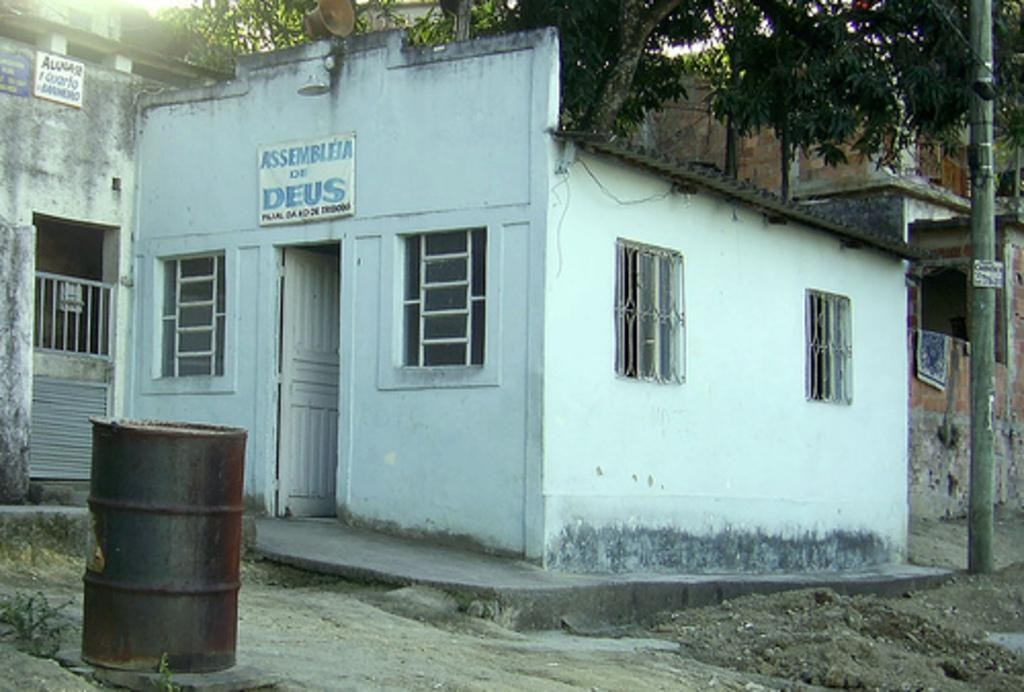<image>
Offer a succinct explanation of the picture presented. White building with a sign that says Assembleia De Deus. 